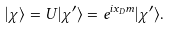<formula> <loc_0><loc_0><loc_500><loc_500>| { \chi } \rangle = U | \chi ^ { \prime } \rangle = e ^ { i x _ { D } m } | \chi ^ { \prime } \rangle .</formula> 